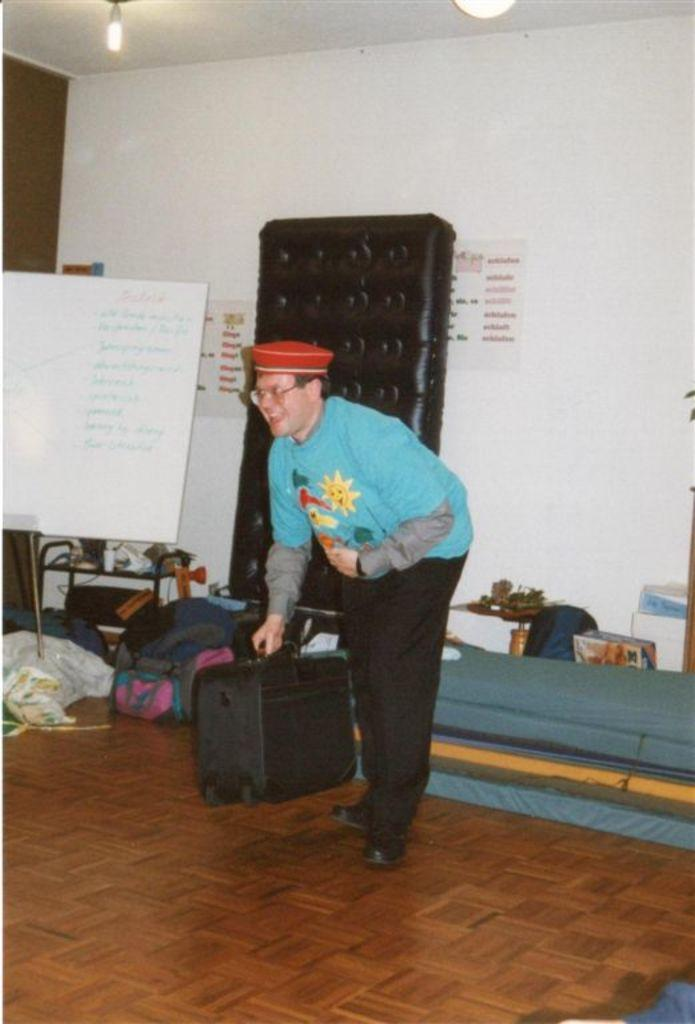What color of the t-shirt the person is wearing in the image? The person is wearing a blue t-shirt. What type of pants is the person wearing in the image? The person is wearing black pants. What object is the person holding in the image? The person is holding a briefcase. What is located to the person's left in the image? There is a whiteboard to the person's person left. What is the color of the wall behind the whiteboard? There is a white wall behind the whiteboard. Are there any additional items on the white wall? Yes, there are notes on the white wall. Can you see any fog in the image? There is no fog present in the image. 